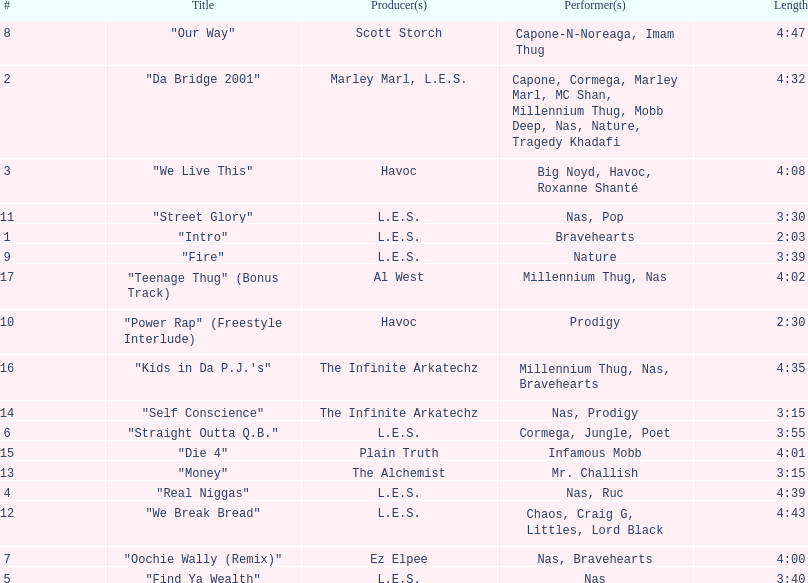Who produced the last track of the album? Al West. 